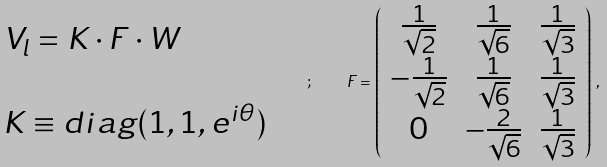<formula> <loc_0><loc_0><loc_500><loc_500>\begin{array} { l } V _ { l } = K \cdot F \cdot W \\ \\ K \equiv d i a g ( 1 , 1 , e ^ { i \theta } ) \end{array} \quad ; \quad F = \left ( \begin{array} { c c c } \frac { 1 } { \sqrt { 2 } } & \frac { 1 } { \sqrt { 6 } } & \frac { 1 } { \sqrt { 3 } } \\ - \frac { 1 } { \sqrt { 2 } } & \frac { 1 } { \sqrt { 6 } } & \frac { 1 } { \sqrt { 3 } } \\ 0 & - \frac { 2 } { \sqrt { 6 } } & \frac { 1 } { \sqrt { 3 } } \end{array} \right ) \, ,</formula> 